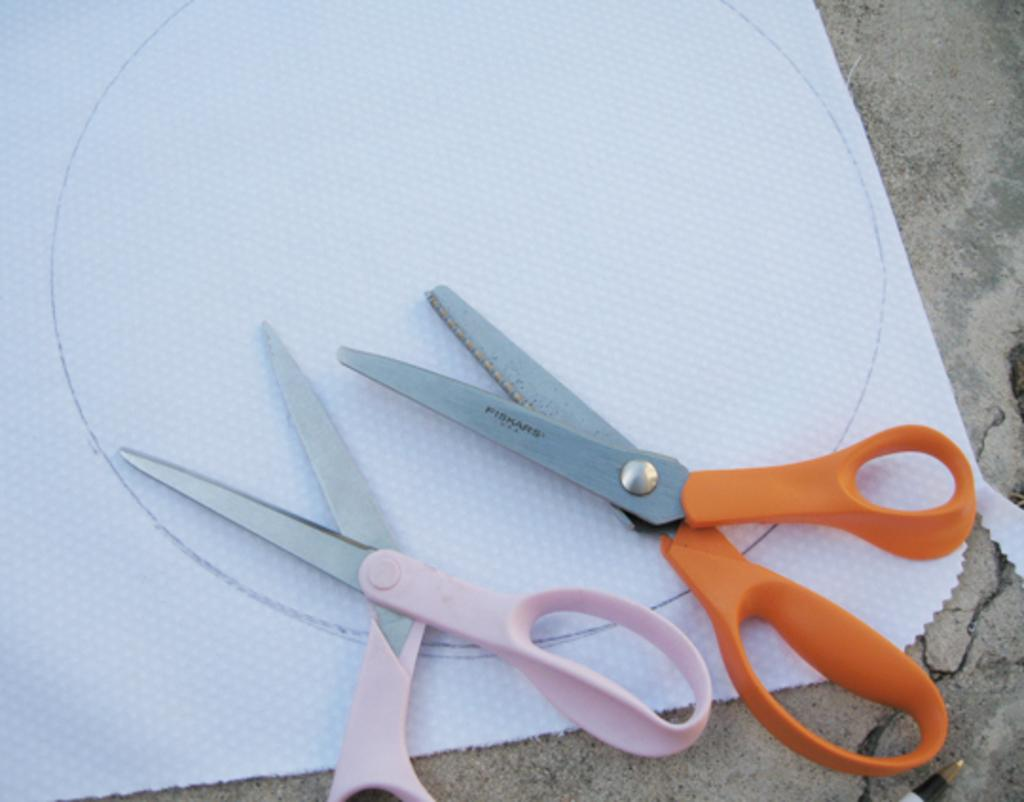What objects are in the image? There are two scissors in the image. What is the scissors placed on? The scissors are placed on a paper. What colors are the scissors? The scissors are in pink and orange colors. How does the duck kick the ball in the image? There is no duck or ball present in the image; it only features two scissors placed on a paper. 